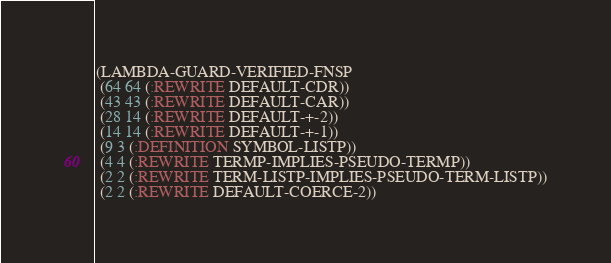<code> <loc_0><loc_0><loc_500><loc_500><_Lisp_>(LAMBDA-GUARD-VERIFIED-FNSP
 (64 64 (:REWRITE DEFAULT-CDR))
 (43 43 (:REWRITE DEFAULT-CAR))
 (28 14 (:REWRITE DEFAULT-+-2))
 (14 14 (:REWRITE DEFAULT-+-1))
 (9 3 (:DEFINITION SYMBOL-LISTP))
 (4 4 (:REWRITE TERMP-IMPLIES-PSEUDO-TERMP))
 (2 2 (:REWRITE TERM-LISTP-IMPLIES-PSEUDO-TERM-LISTP))
 (2 2 (:REWRITE DEFAULT-COERCE-2))</code> 